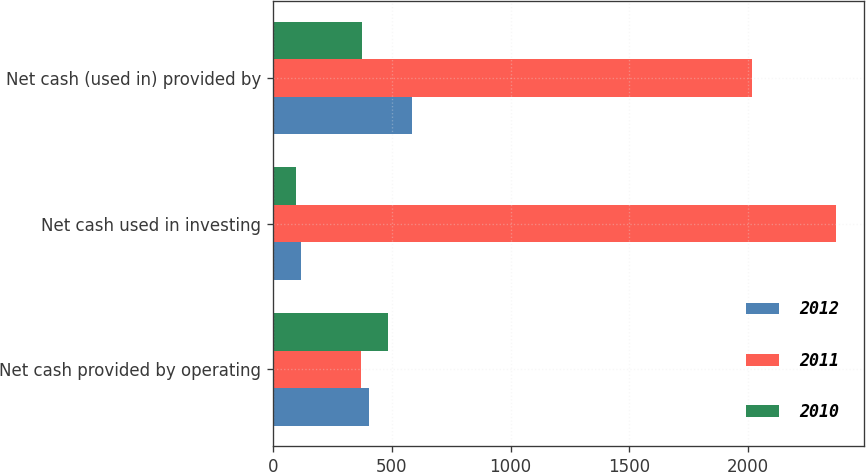<chart> <loc_0><loc_0><loc_500><loc_500><stacked_bar_chart><ecel><fcel>Net cash provided by operating<fcel>Net cash used in investing<fcel>Net cash (used in) provided by<nl><fcel>2012<fcel>404.4<fcel>116.5<fcel>585.1<nl><fcel>2011<fcel>372.2<fcel>2370<fcel>2016.4<nl><fcel>2010<fcel>483.1<fcel>96.9<fcel>373<nl></chart> 